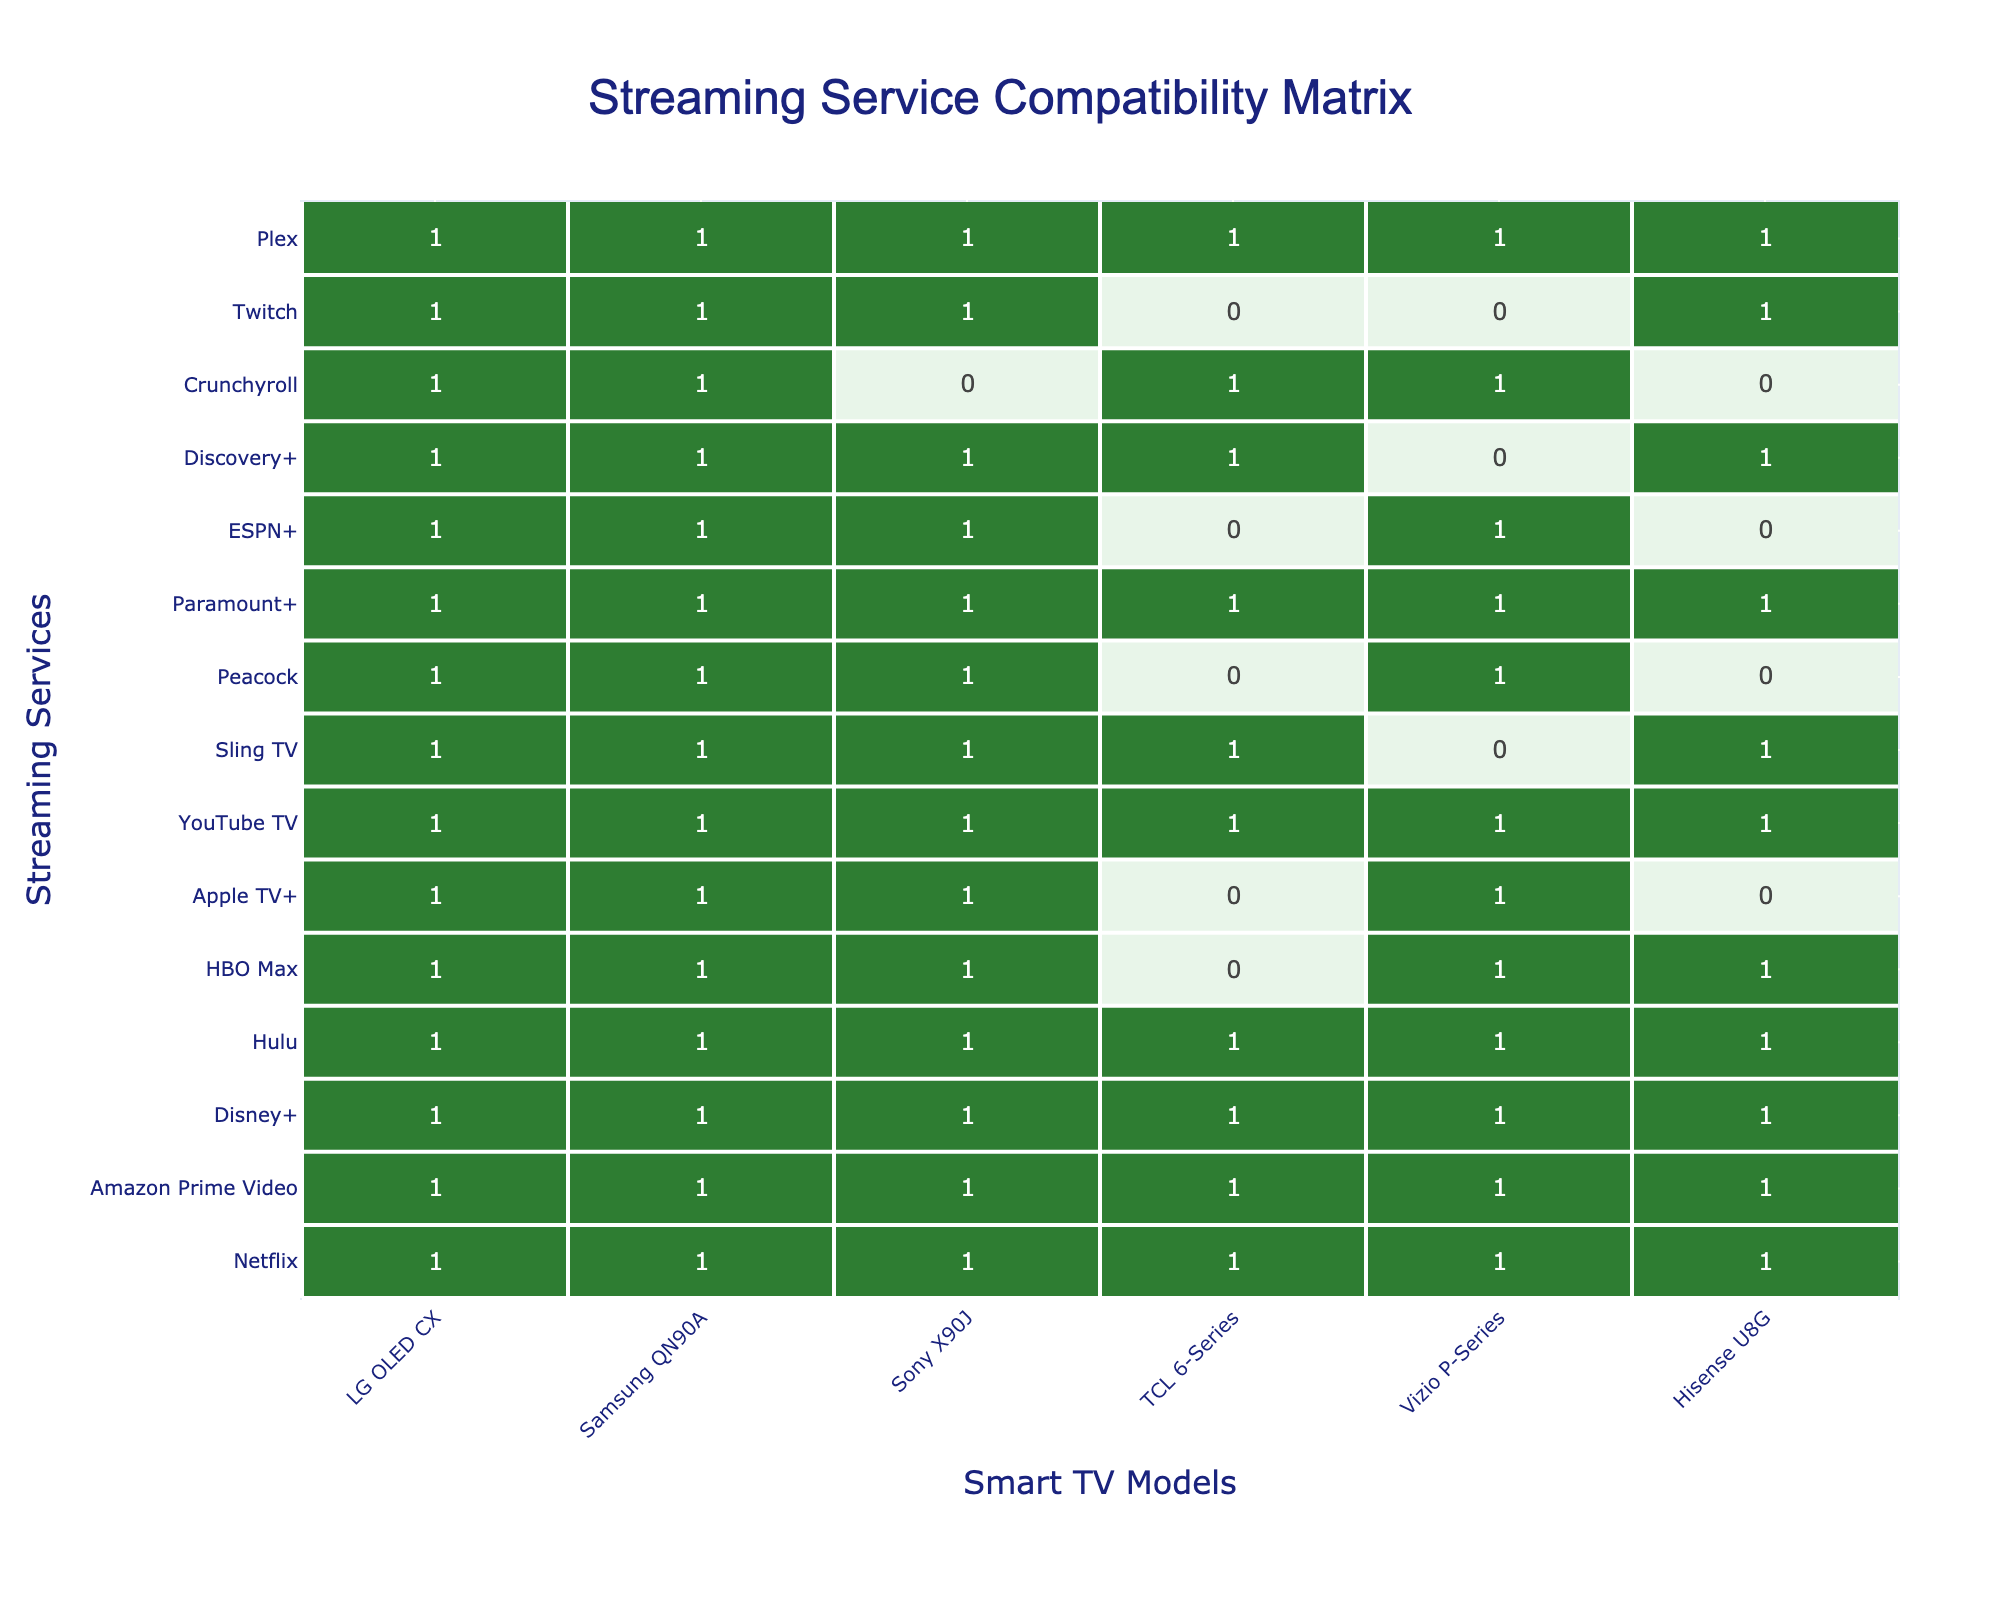What streaming service is compatible with the Sony X90J? Looking at the column for Sony X90J, we see that Netflix, Amazon Prime Video, Disney+, Hulu, HBO Max, Apple TV+, YouTube TV, Sling TV, Paramount+, and Twitch are all marked with a 1, indicating compatibility.
Answer: Netflix, Amazon Prime Video, Disney+, Hulu, HBO Max, Apple TV+, YouTube TV, Sling TV, Paramount+, Twitch Which smart TV models are compatible with HBO Max? By examining the row for HBO Max, we find that it has a compatibility of 1 with LG OLED CX, Samsung QN90A, TCL 6-Series, Vizio P-Series, and Hisense U8G. It is marked with a 0 for TCL 6-Series.
Answer: LG OLED CX, Samsung QN90A, Vizio P-Series, Hisense U8G How many streaming services are compatible with the Vizio P-Series? Counting the number of 1's in the Vizio P-Series column, we have Netflix, Amazon Prime Video, Disney+, Hulu, HBO Max, Apple TV+, YouTube TV, Paramount+, and Discovery+. That sums up to a total of 8 compatible services.
Answer: 8 Which streaming service has the least compatibility across all smart TVs? Looking at the table, Crunchyroll has compatibility with only the LG OLED CX, Samsung QN90A, TCL 6-Series, and Hisense U8G (totaling just 4 compatible TVs). Other services are compatible with more TV models.
Answer: Crunchyroll Is Apple TV+ compatible with any TCL 6-Series TV? Checking the compatibility for Apple TV+ with TCL 6-Series, it is marked with a 0, indicating that it is not compatible with this model.
Answer: No Which smart TV model supports the most streaming services? After analyzing the compatibility matrix, we find that both LG OLED CX and Samsung QN90A support all 13 streaming services, yielding the highest compatibility.
Answer: LG OLED CX, Samsung QN90A What is the total number of streaming services that are compatible with the Hisense U8G? By inspecting the Hisense U8G column, the compatible services are Netflix, Amazon Prime Video, Hulu, HBO Max, YouTube TV, Sling TV, Paramount+, Discovery+, and Twitch, which gives a total of 8 services.
Answer: 8 How many streaming services are compatible with both the Samsung QN90A and the Vizio P-Series? For Samsung QN90A, the compatible services are Netflix, Amazon Prime Video, Disney+, Hulu, HBO Max, Apple TV+, YouTube TV, Sling TV, Paramount+, ESPN+, Discovery+, and Twitch, totaling 12. For Vizio P-Series, they are Netflix, Amazon Prime Video, Disney+, Hulu, HBO Max, Apple TV+, YouTube TV, Peacock, Paramount+, and Discovery+ for a total of 10. The overlapping services are Netflix, Amazon Prime Video, Disney+, Hulu, HBO Max, Apple TV+, YouTube TV, and Paramount+, resulting in 8 shared services.
Answer: 8 Is there any service that is compatible with all the TV models? By reviewing the table, we see that Netflix, Amazon Prime Video, Disney+, Hulu, and Paramount+ have a 1 in every row corresponding to all TV models, confirming they are compatible with all TVs.
Answer: Yes, Netflix, Amazon Prime Video, Disney+, Hulu, Paramount+ 